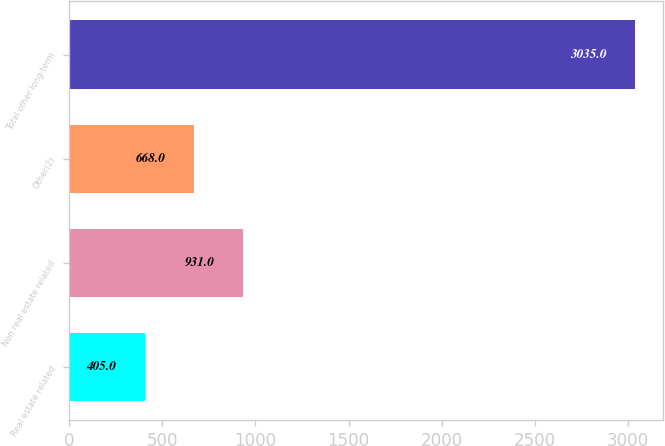Convert chart to OTSL. <chart><loc_0><loc_0><loc_500><loc_500><bar_chart><fcel>Real estate related<fcel>Non real estate related<fcel>Other(2)<fcel>Total other long-term<nl><fcel>405<fcel>931<fcel>668<fcel>3035<nl></chart> 